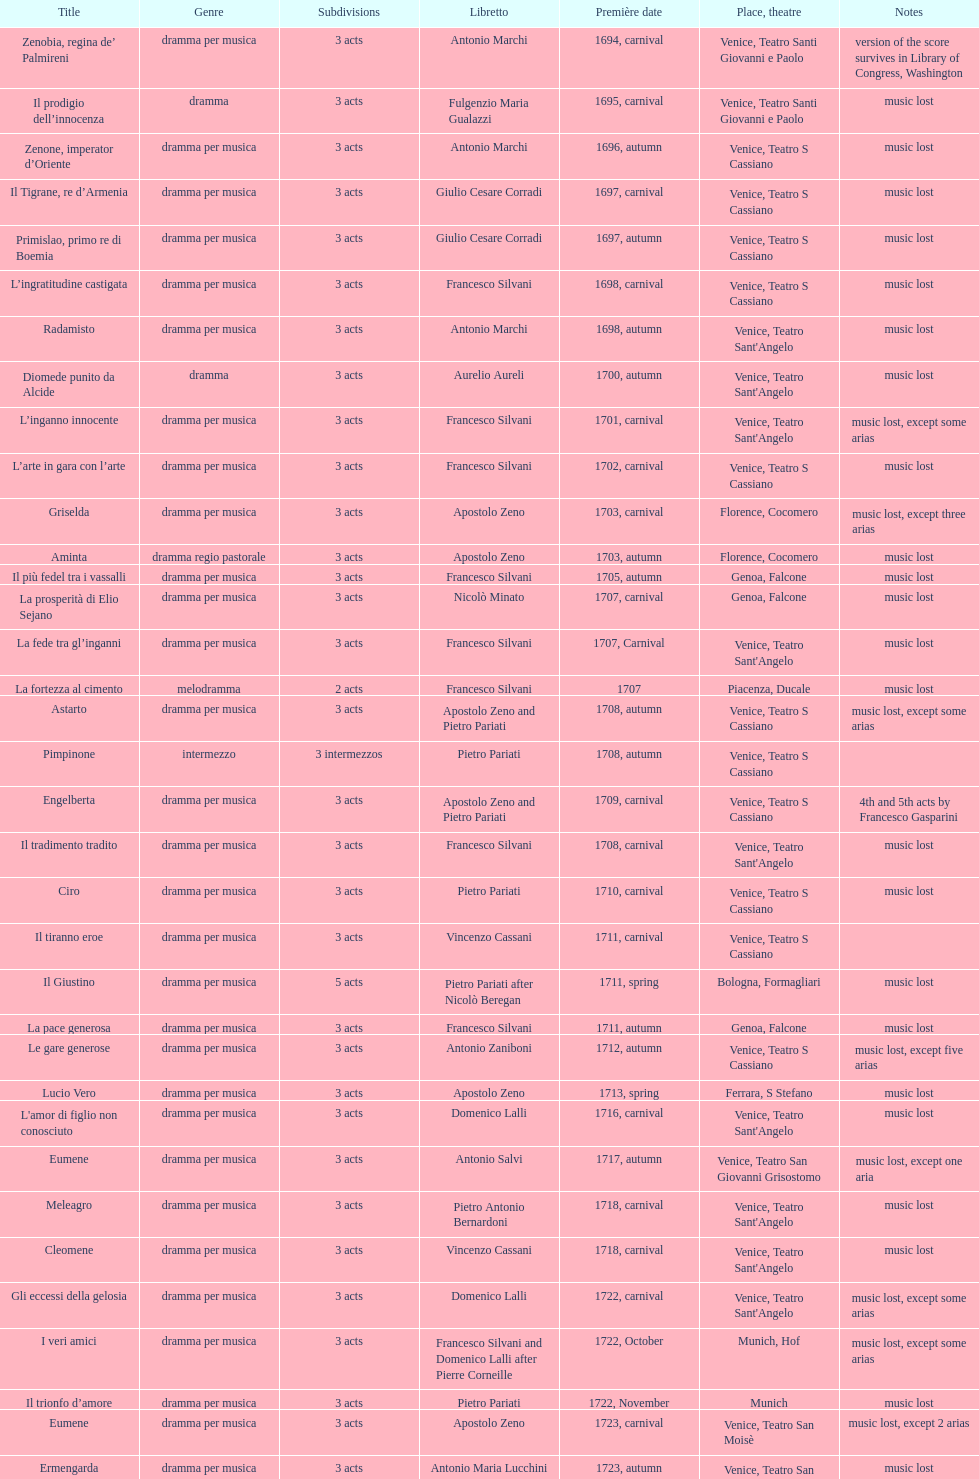What is next after ardelinda? Candalide. 